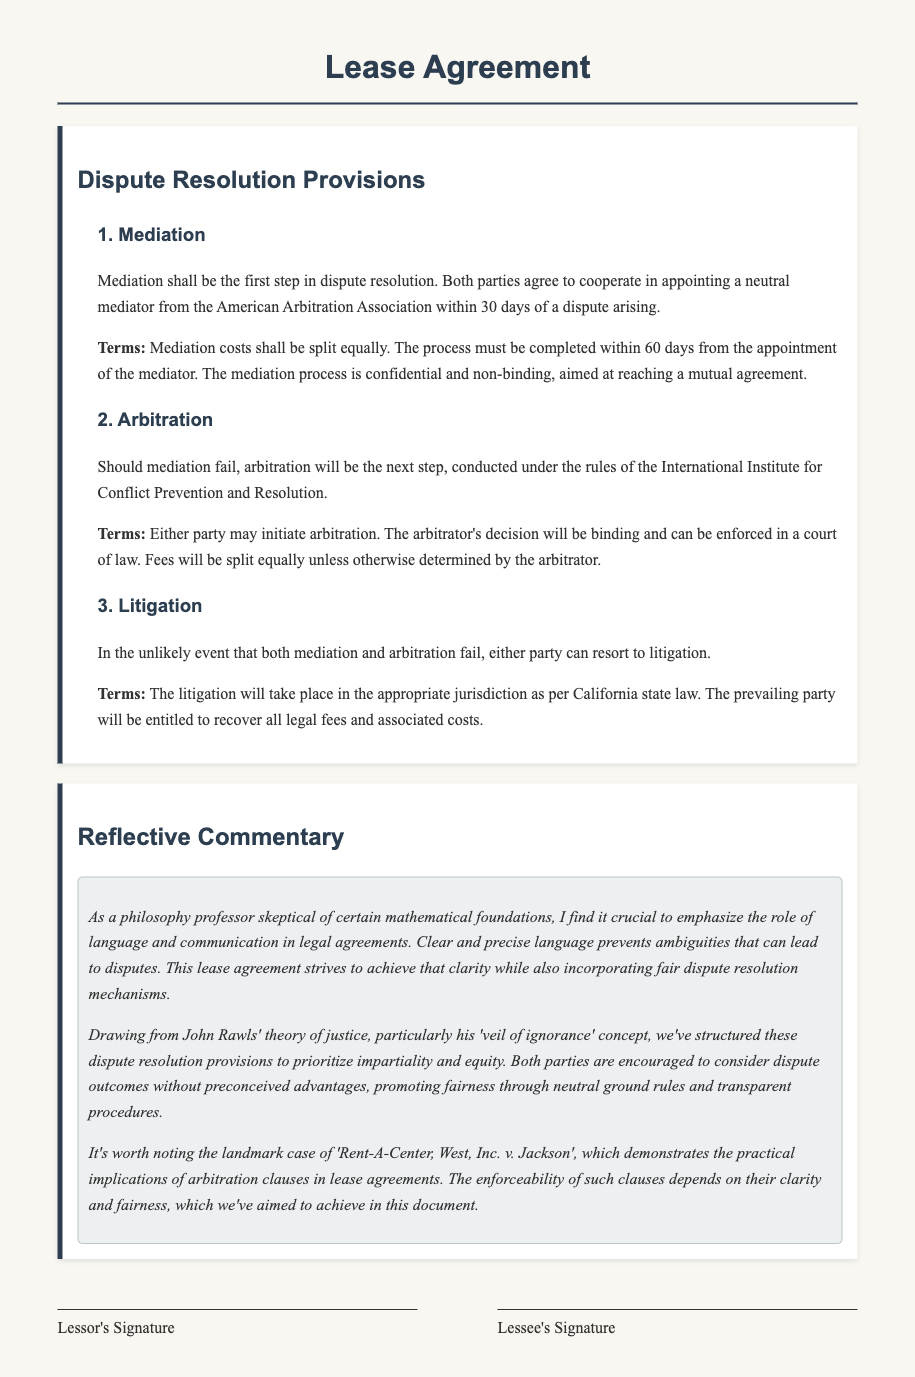What is the first step in dispute resolution? The document states that mediation shall be the first step in dispute resolution.
Answer: Mediation Who appoints the mediator in case of a dispute? The document mentions that both parties will cooperate in appointing a neutral mediator.
Answer: Both parties What is the timeframe for completing mediation? The lease agreement specifies that the mediation process must be completed within 60 days from the appointment of the mediator.
Answer: 60 days Which rules govern arbitration? The arbitration process is conducted under the rules of the International Institute for Conflict Prevention and Resolution.
Answer: International Institute for Conflict Prevention and Resolution What is the third step in the dispute resolution process if mediation and arbitration fail? According to the document, either party can resort to litigation if mediation and arbitration fail.
Answer: Litigation What happens to the prevailing party in litigation? The lease agreement states that the prevailing party will be entitled to recover all legal fees and associated costs.
Answer: Recover legal fees How does the document ensure fairness in dispute resolution? The document incorporates fair dispute resolution mechanisms and prioritizes impartiality and equity, as influenced by John Rawls' theory of justice.
Answer: Impartiality and equity What is emphasized in the reflective commentary regarding legal language? The reflective commentary emphasizes the importance of clear and precise language in legal agreements to prevent ambiguities.
Answer: Clear and precise language What landmark case is referenced in the document? The document references the landmark case of 'Rent-A-Center, West, Inc. v. Jackson'.
Answer: Rent-A-Center, West, Inc. v. Jackson 